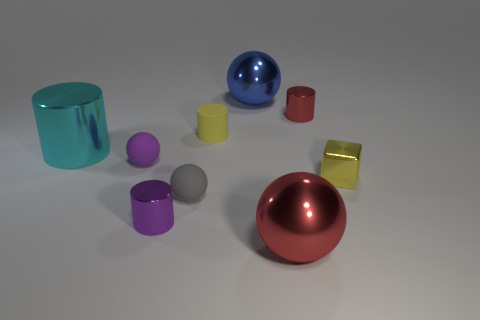Are there fewer tiny gray rubber things behind the cyan object than tiny gray rubber things?
Make the answer very short. Yes. There is a cylinder that is to the left of the small matte sphere to the left of the purple shiny object; what color is it?
Give a very brief answer. Cyan. There is a shiny sphere in front of the big metallic thing that is behind the tiny shiny thing behind the small purple sphere; how big is it?
Provide a succinct answer. Large. Are there fewer small purple things to the left of the red metal cylinder than yellow rubber cylinders right of the shiny cube?
Offer a very short reply. No. What number of blue balls are the same material as the purple ball?
Your answer should be very brief. 0. There is a red object behind the big metal sphere that is in front of the cyan thing; are there any small yellow rubber objects that are behind it?
Offer a terse response. No. What is the shape of the blue object that is made of the same material as the big cyan object?
Offer a terse response. Sphere. Is the number of tiny purple objects greater than the number of small matte cylinders?
Provide a short and direct response. Yes. There is a big blue object; does it have the same shape as the tiny yellow object left of the large blue metallic object?
Your response must be concise. No. What is the material of the large cyan object?
Keep it short and to the point. Metal. 